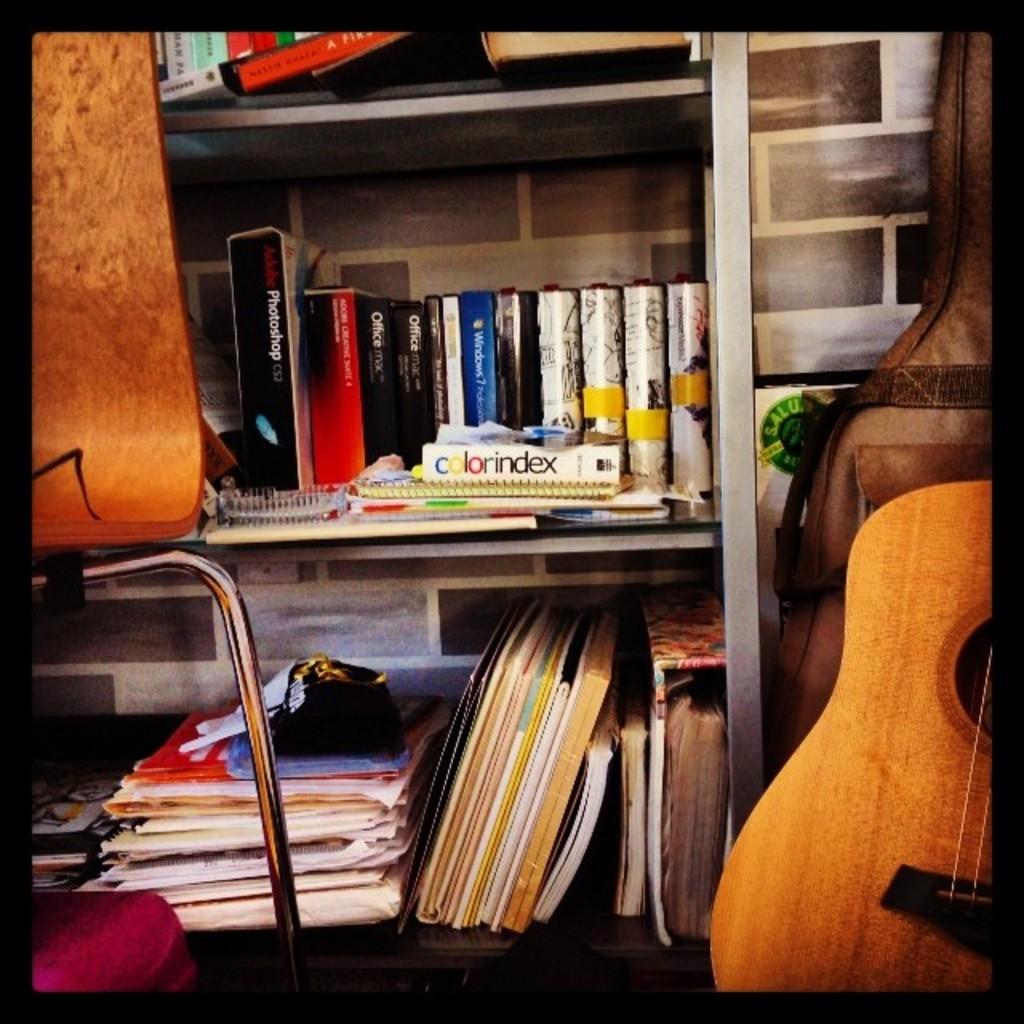Where is the colorindex?
Your response must be concise. Answering does not require reading text in the image. What is the title of the horizontal book?
Make the answer very short. Colorindex. 